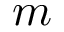<formula> <loc_0><loc_0><loc_500><loc_500>m</formula> 